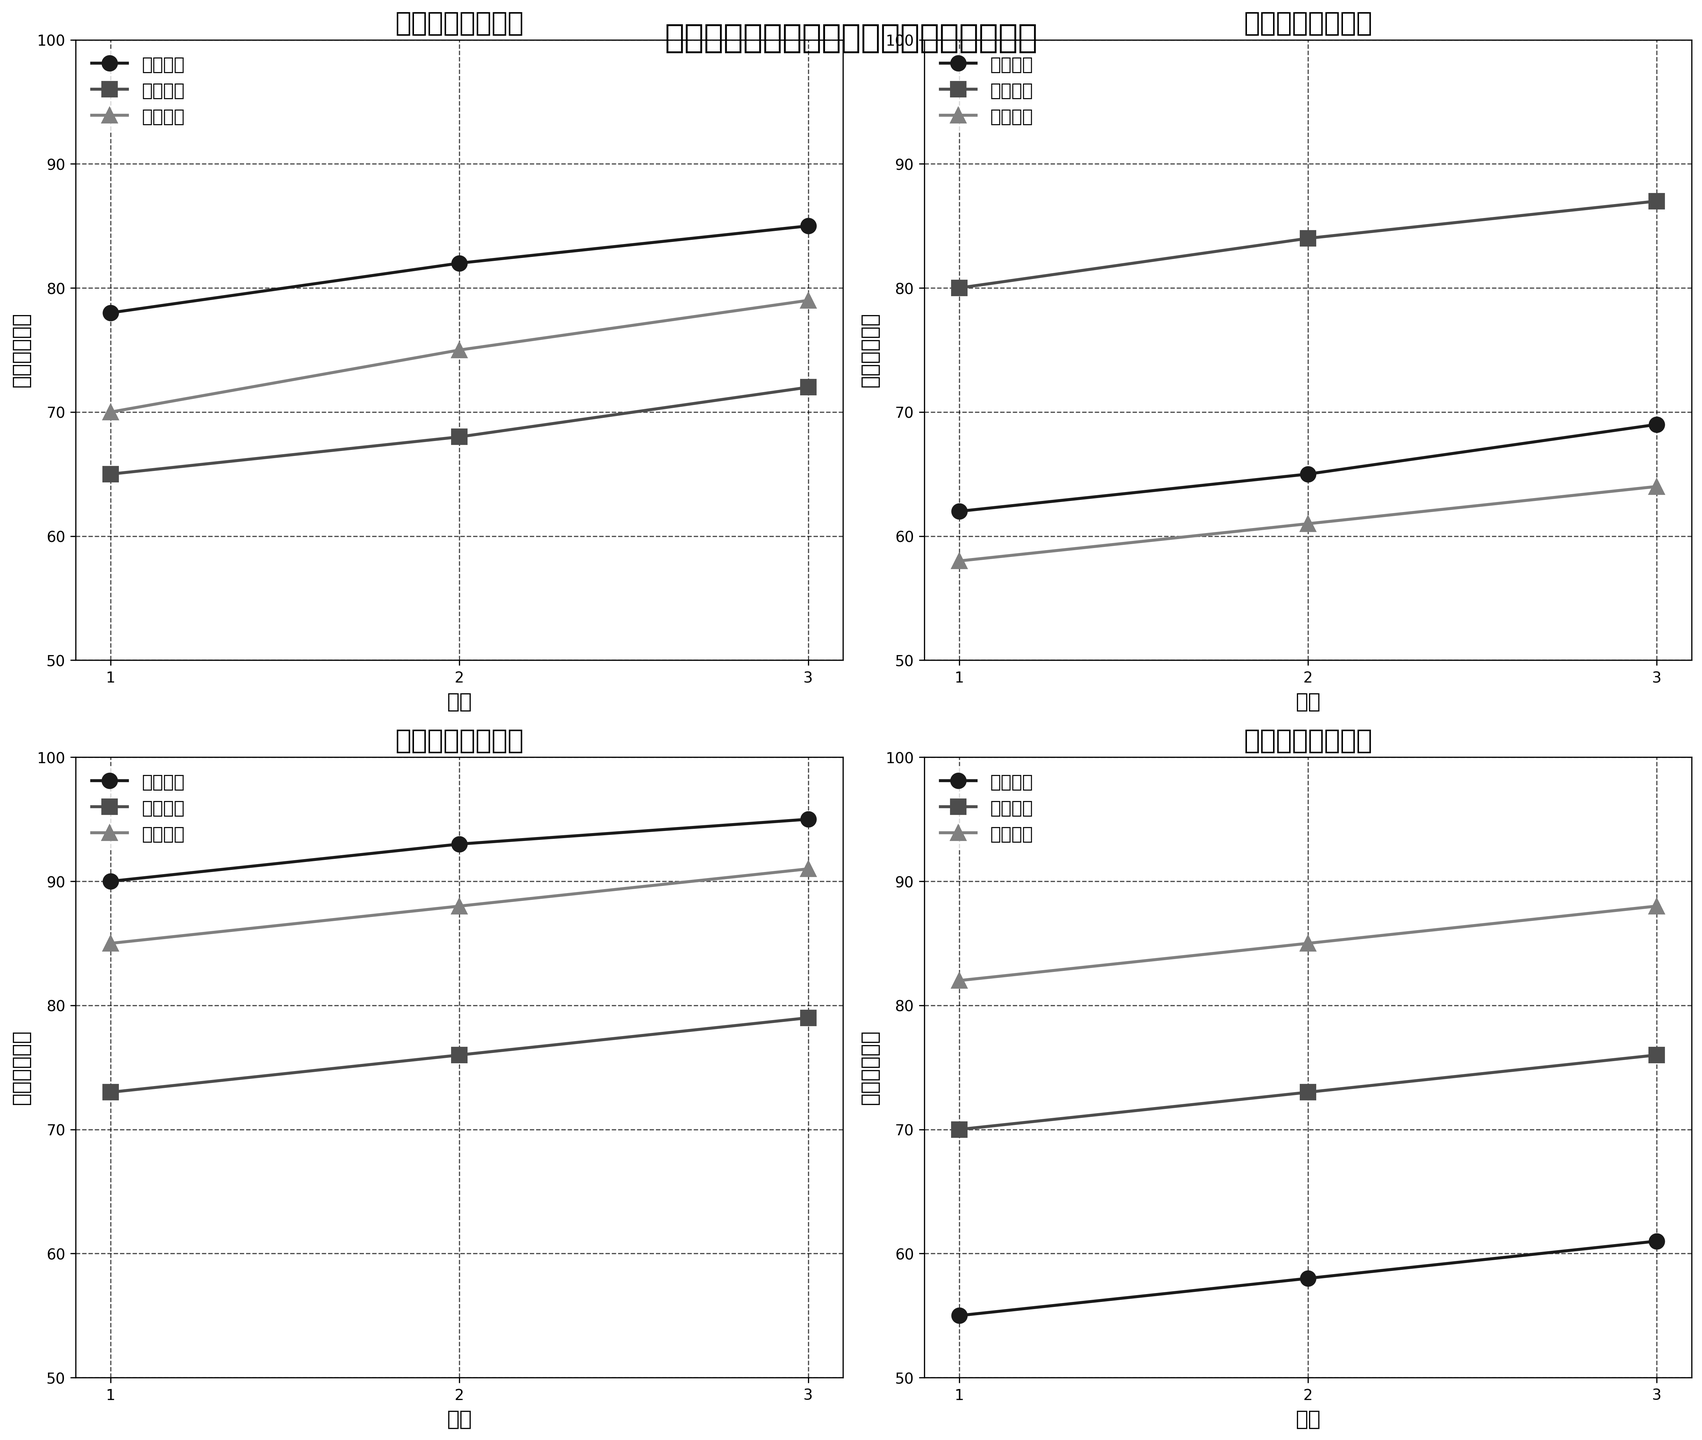在社交媒体平台上，哪个话题在2月份的讨论热度最高？ 比较所有平台上2月份的不同话题的讨论热度，找到热度最高的那个话题。
Answer: 抖音平台上的“收入差距”话题 哪个平台的“性别歧视”话题热度在3个月中的增长最快？ 查看各个平台上“性别歧视”话题的讨论热度，计算增长速度（3月份减1月份），比较这些增长值，找出增长最快的平台。
Answer: 抖音 在豆瓣平台上，哪些两个话题在3月份的讨论热度相同？ 查看豆瓣平台上3月份所有话题的讨论热度，找出讨论热度值相同的两个话题。
Answer: 无相同值 3月份各个平台中讨论热度最低的话题是什么？ 比较各个平台3月份所有话题的讨论热度，找出最低的那个。
Answer: 知乎平台上的“性别歧视”话题 微博平台上“收入差距”话题的平均讨论热度是多少？ 计算微博平台上“收入差距”话题在1、2、3月份的讨论热度的平均值。 计算公式: (78+82+85)/3，答案约为81.67
Answer: 81.67 哪个平台在“收入差距”话题上的讨论热度在3个月内保持上升趋势？ 检查每个平台上“收入差距”话题在1、2、3月份的讨论热度，找出这些月热度持续上升的平台。
Answer: 所有平台 知乎平台上哪个话题的讨论热度最高？ 查看知乎平台上所有话题的讨论热度，找到热度最高的那个话题。
Answer: 教育机会 各个平台中，在3月份讨论“教育机会”话题的热度如何排名？ 比较各个平台在3月份对“教育机会”话题的讨论热度，并排序。
Answer: 知乎(87), 抖音(79), 豆瓣(76), 微博(72) 哪个平台上“收入差距”话题的讨论热度在第3个月到达最高值？ 查看各个平台第3个月的“收入差距”话题讨论热度，找出最高的值。
Answer: 抖音 